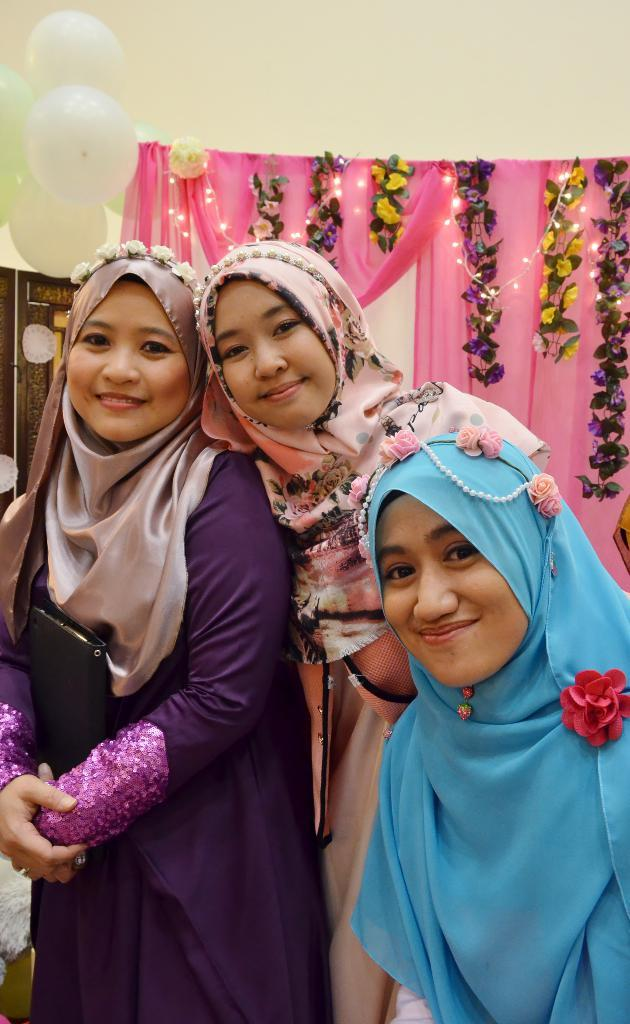How many people are in the image? There are three persons standing in the image. What is the facial expression of the persons in the image? The persons are smiling. What can be seen in the background of the image? There are flowers with leaves, clothes, lights, a rope, balloons, and a wall visible in the background of the image. Is there a beggar asking for money in the image? No, there is no beggar present in the image. What type of yard can be seen in the image? There is no yard visible in the image; it is an indoor setting with a wall in the background. 